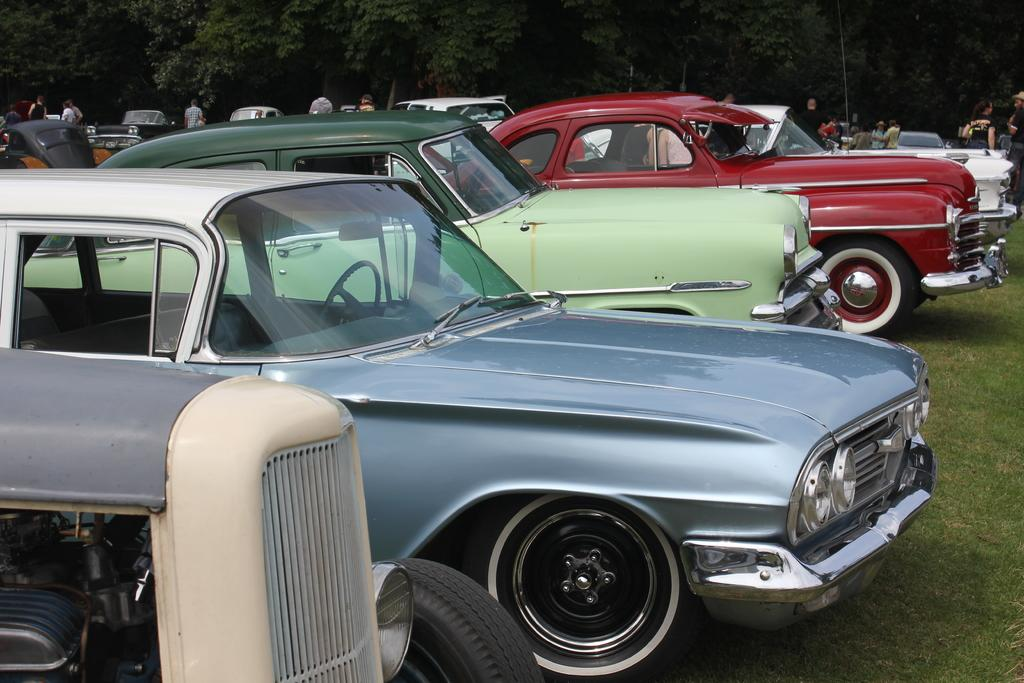What type of vehicles are present in the image? There are many cars in the image. Can you describe the appearance of the cars? The cars appear to be vintage. What is visible at the bottom of the image? There is green grass at the bottom of the image. What can be seen in the background of the image? There are trees in the background of the image. How many people are present in the image? There are many people in the image. What type of fork can be seen in the image? There is no fork present in the image. What type of oil is being used to maintain the cars in the image? There is no indication of oil or any maintenance activity in the image. 